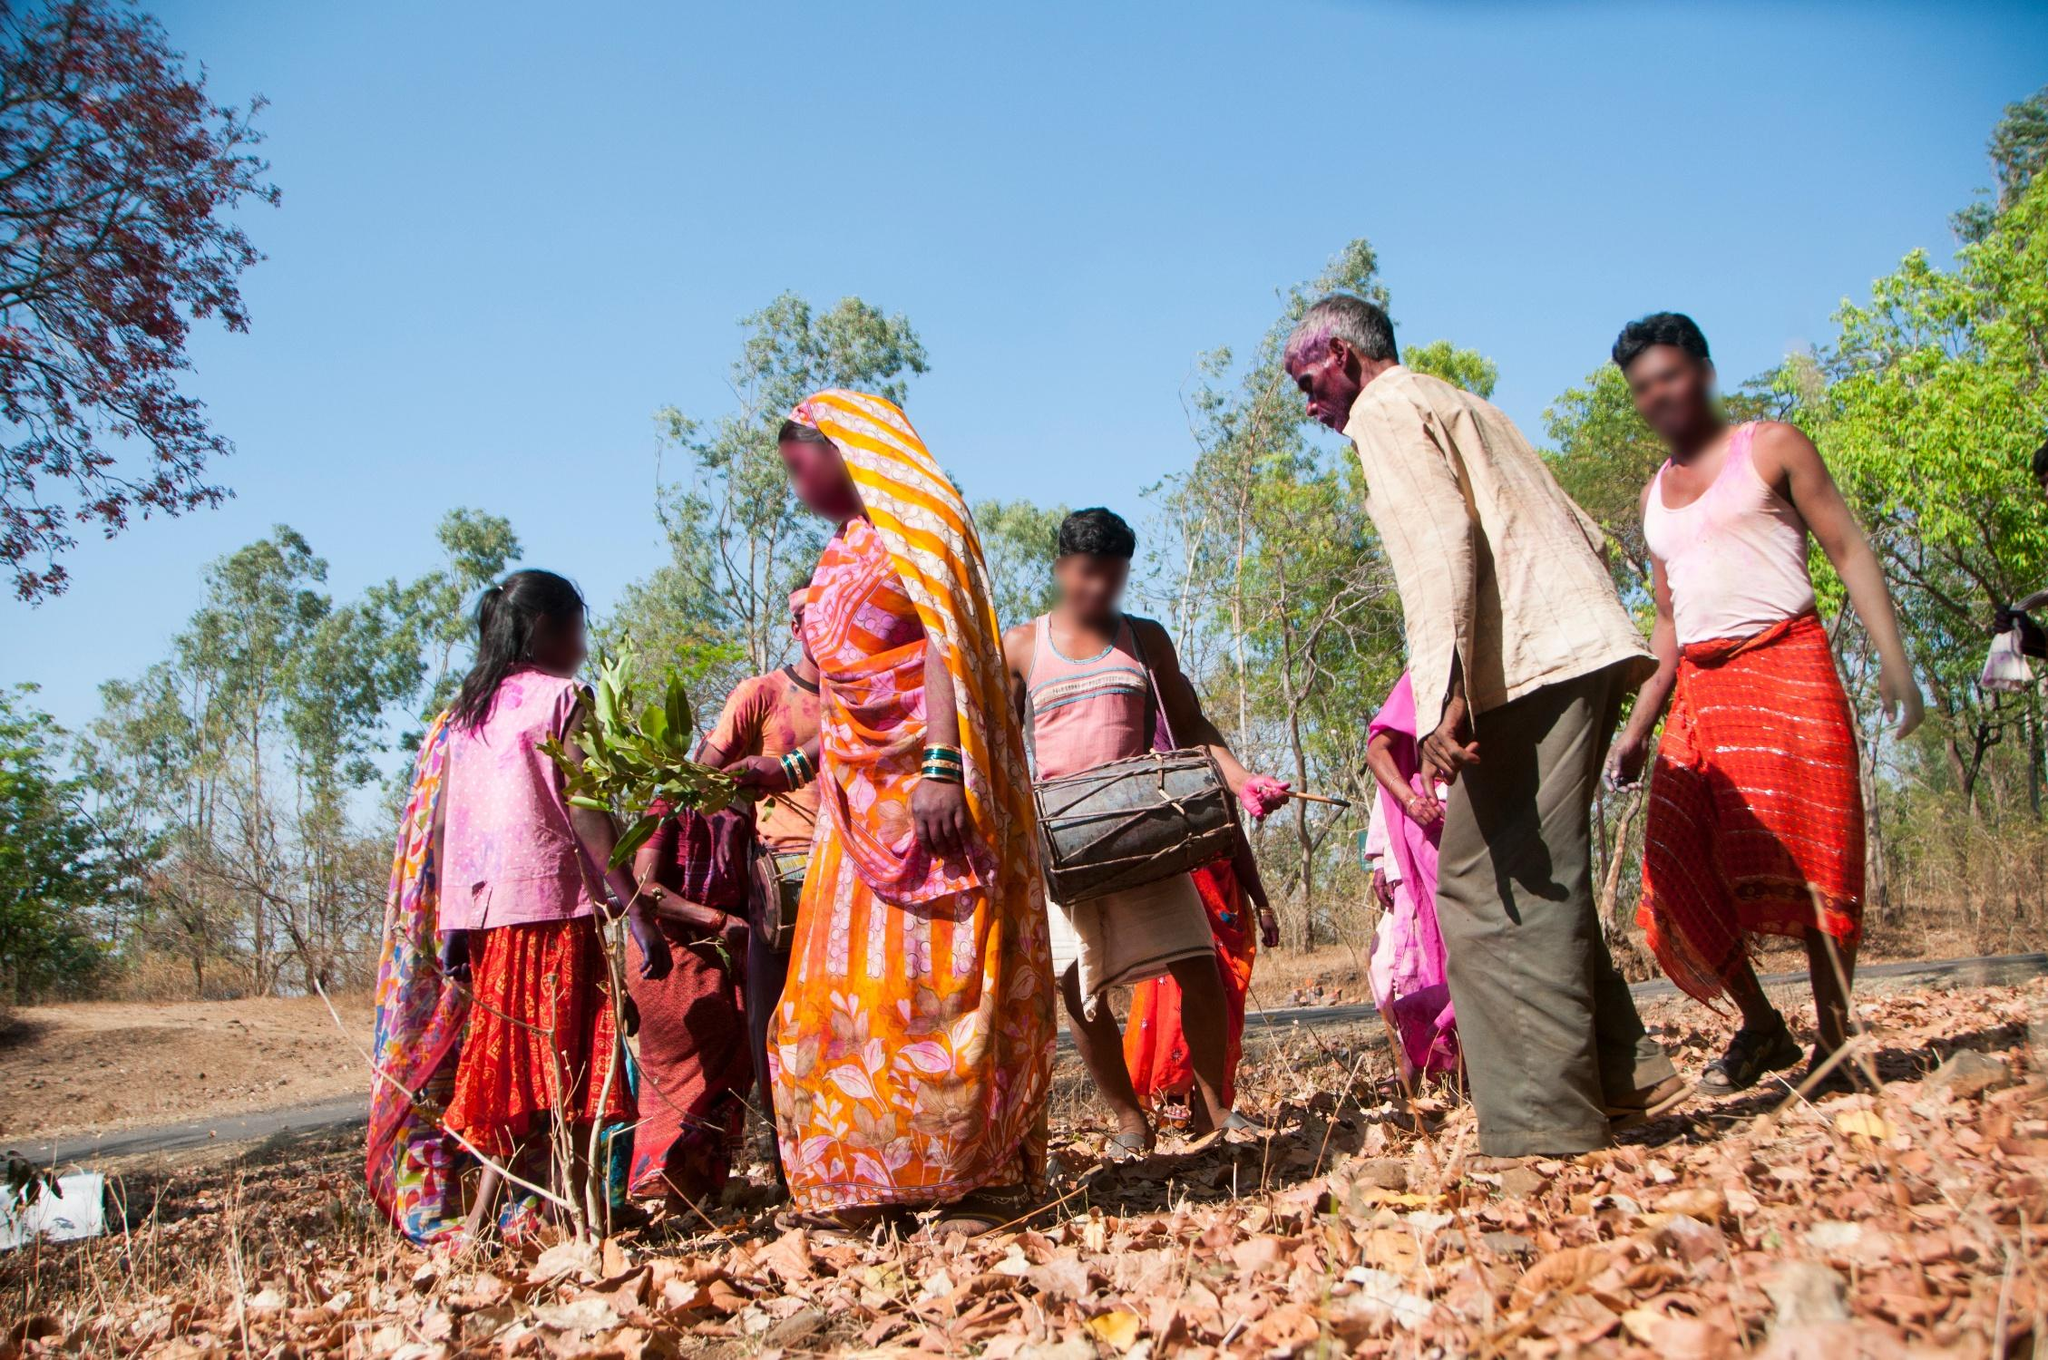Describe the mood and atmosphere conveyed by the scene. The image radiates a warm and communal atmosphere. The bright and vibrant clothing of the people, coupled with their engaged posture, suggests an event filled with camaraderie and shared purpose. The sunlight, filtering through the lush trees, casts a cheerful and energetic mood, reinforcing the harmonious interaction between the individuals and their environment. 